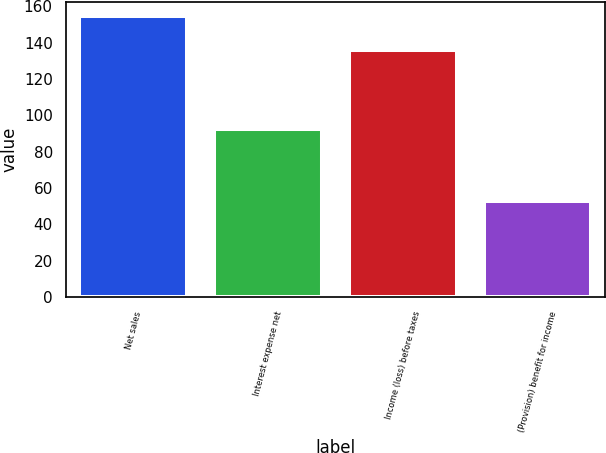Convert chart to OTSL. <chart><loc_0><loc_0><loc_500><loc_500><bar_chart><fcel>Net sales<fcel>Interest expense net<fcel>Income (loss) before taxes<fcel>(Provision) benefit for income<nl><fcel>154.6<fcel>92.2<fcel>135.8<fcel>52.7<nl></chart> 